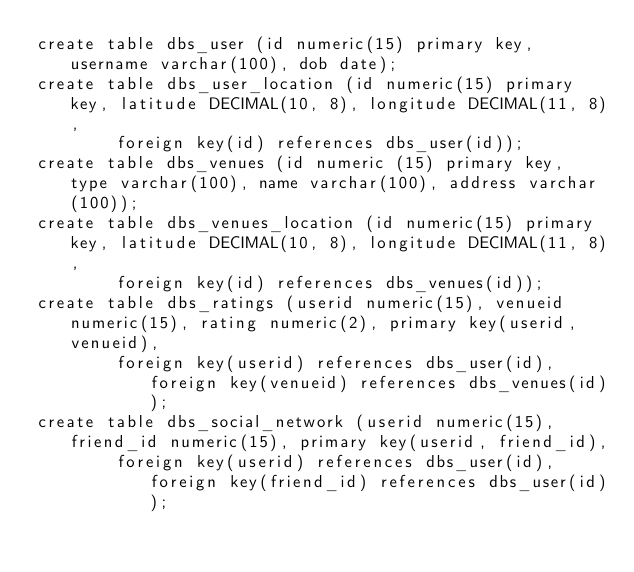<code> <loc_0><loc_0><loc_500><loc_500><_SQL_>create table dbs_user (id numeric(15) primary key, username varchar(100), dob date);
create table dbs_user_location (id numeric(15) primary key, latitude DECIMAL(10, 8), longitude DECIMAL(11, 8), 
		foreign key(id) references dbs_user(id));
create table dbs_venues (id numeric (15) primary key, type varchar(100), name varchar(100), address varchar(100));
create table dbs_venues_location (id numeric(15) primary key, latitude DECIMAL(10, 8), longitude DECIMAL(11, 8), 
		foreign key(id) references dbs_venues(id));
create table dbs_ratings (userid numeric(15), venueid numeric(15), rating numeric(2), primary key(userid, venueid),
		foreign key(userid) references dbs_user(id), foreign key(venueid) references dbs_venues(id));
create table dbs_social_network (userid numeric(15), friend_id numeric(15), primary key(userid, friend_id), 
		foreign key(userid) references dbs_user(id), foreign key(friend_id) references dbs_user(id));

</code> 